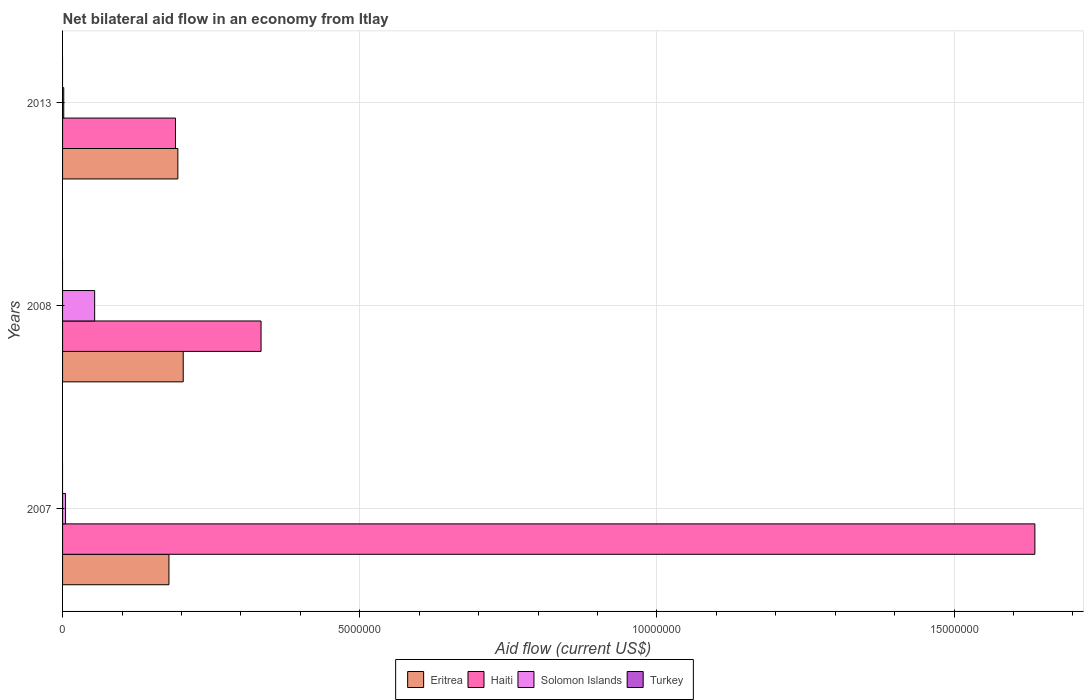Are the number of bars on each tick of the Y-axis equal?
Keep it short and to the point. Yes. What is the label of the 1st group of bars from the top?
Ensure brevity in your answer.  2013. What is the net bilateral aid flow in Turkey in 2013?
Give a very brief answer. 0. Across all years, what is the maximum net bilateral aid flow in Haiti?
Ensure brevity in your answer.  1.64e+07. Across all years, what is the minimum net bilateral aid flow in Eritrea?
Provide a short and direct response. 1.79e+06. What is the total net bilateral aid flow in Eritrea in the graph?
Provide a short and direct response. 5.76e+06. What is the difference between the net bilateral aid flow in Solomon Islands in 2007 and that in 2013?
Give a very brief answer. 3.00e+04. What is the difference between the net bilateral aid flow in Turkey in 2008 and the net bilateral aid flow in Solomon Islands in 2007?
Your answer should be very brief. -5.00e+04. What is the average net bilateral aid flow in Haiti per year?
Provide a short and direct response. 7.20e+06. In the year 2013, what is the difference between the net bilateral aid flow in Eritrea and net bilateral aid flow in Solomon Islands?
Make the answer very short. 1.92e+06. In how many years, is the net bilateral aid flow in Solomon Islands greater than 8000000 US$?
Your answer should be very brief. 0. What is the ratio of the net bilateral aid flow in Haiti in 2008 to that in 2013?
Provide a short and direct response. 1.76. What is the difference between the highest and the second highest net bilateral aid flow in Eritrea?
Offer a terse response. 9.00e+04. What is the difference between the highest and the lowest net bilateral aid flow in Haiti?
Make the answer very short. 1.45e+07. Is the sum of the net bilateral aid flow in Eritrea in 2007 and 2013 greater than the maximum net bilateral aid flow in Haiti across all years?
Provide a short and direct response. No. How many years are there in the graph?
Provide a succinct answer. 3. Does the graph contain any zero values?
Offer a terse response. Yes. Does the graph contain grids?
Your answer should be very brief. Yes. How many legend labels are there?
Provide a succinct answer. 4. What is the title of the graph?
Make the answer very short. Net bilateral aid flow in an economy from Itlay. Does "Bolivia" appear as one of the legend labels in the graph?
Offer a very short reply. No. What is the Aid flow (current US$) of Eritrea in 2007?
Provide a succinct answer. 1.79e+06. What is the Aid flow (current US$) in Haiti in 2007?
Your answer should be very brief. 1.64e+07. What is the Aid flow (current US$) in Eritrea in 2008?
Your answer should be compact. 2.03e+06. What is the Aid flow (current US$) of Haiti in 2008?
Give a very brief answer. 3.34e+06. What is the Aid flow (current US$) in Solomon Islands in 2008?
Give a very brief answer. 5.40e+05. What is the Aid flow (current US$) of Turkey in 2008?
Provide a short and direct response. 0. What is the Aid flow (current US$) in Eritrea in 2013?
Offer a very short reply. 1.94e+06. What is the Aid flow (current US$) of Haiti in 2013?
Ensure brevity in your answer.  1.90e+06. What is the Aid flow (current US$) of Solomon Islands in 2013?
Give a very brief answer. 2.00e+04. Across all years, what is the maximum Aid flow (current US$) in Eritrea?
Your response must be concise. 2.03e+06. Across all years, what is the maximum Aid flow (current US$) in Haiti?
Your answer should be compact. 1.64e+07. Across all years, what is the maximum Aid flow (current US$) in Solomon Islands?
Offer a very short reply. 5.40e+05. Across all years, what is the minimum Aid flow (current US$) in Eritrea?
Give a very brief answer. 1.79e+06. Across all years, what is the minimum Aid flow (current US$) of Haiti?
Keep it short and to the point. 1.90e+06. What is the total Aid flow (current US$) in Eritrea in the graph?
Give a very brief answer. 5.76e+06. What is the total Aid flow (current US$) in Haiti in the graph?
Make the answer very short. 2.16e+07. What is the total Aid flow (current US$) of Solomon Islands in the graph?
Offer a very short reply. 6.10e+05. What is the difference between the Aid flow (current US$) of Haiti in 2007 and that in 2008?
Provide a succinct answer. 1.30e+07. What is the difference between the Aid flow (current US$) of Solomon Islands in 2007 and that in 2008?
Keep it short and to the point. -4.90e+05. What is the difference between the Aid flow (current US$) in Eritrea in 2007 and that in 2013?
Your answer should be compact. -1.50e+05. What is the difference between the Aid flow (current US$) in Haiti in 2007 and that in 2013?
Make the answer very short. 1.45e+07. What is the difference between the Aid flow (current US$) in Haiti in 2008 and that in 2013?
Offer a very short reply. 1.44e+06. What is the difference between the Aid flow (current US$) of Solomon Islands in 2008 and that in 2013?
Your answer should be very brief. 5.20e+05. What is the difference between the Aid flow (current US$) in Eritrea in 2007 and the Aid flow (current US$) in Haiti in 2008?
Offer a very short reply. -1.55e+06. What is the difference between the Aid flow (current US$) of Eritrea in 2007 and the Aid flow (current US$) of Solomon Islands in 2008?
Your answer should be compact. 1.25e+06. What is the difference between the Aid flow (current US$) in Haiti in 2007 and the Aid flow (current US$) in Solomon Islands in 2008?
Give a very brief answer. 1.58e+07. What is the difference between the Aid flow (current US$) of Eritrea in 2007 and the Aid flow (current US$) of Haiti in 2013?
Your answer should be very brief. -1.10e+05. What is the difference between the Aid flow (current US$) of Eritrea in 2007 and the Aid flow (current US$) of Solomon Islands in 2013?
Your response must be concise. 1.77e+06. What is the difference between the Aid flow (current US$) in Haiti in 2007 and the Aid flow (current US$) in Solomon Islands in 2013?
Ensure brevity in your answer.  1.63e+07. What is the difference between the Aid flow (current US$) in Eritrea in 2008 and the Aid flow (current US$) in Solomon Islands in 2013?
Your response must be concise. 2.01e+06. What is the difference between the Aid flow (current US$) in Haiti in 2008 and the Aid flow (current US$) in Solomon Islands in 2013?
Provide a short and direct response. 3.32e+06. What is the average Aid flow (current US$) of Eritrea per year?
Offer a very short reply. 1.92e+06. What is the average Aid flow (current US$) in Haiti per year?
Keep it short and to the point. 7.20e+06. What is the average Aid flow (current US$) of Solomon Islands per year?
Offer a terse response. 2.03e+05. What is the average Aid flow (current US$) of Turkey per year?
Provide a succinct answer. 0. In the year 2007, what is the difference between the Aid flow (current US$) in Eritrea and Aid flow (current US$) in Haiti?
Offer a very short reply. -1.46e+07. In the year 2007, what is the difference between the Aid flow (current US$) in Eritrea and Aid flow (current US$) in Solomon Islands?
Provide a short and direct response. 1.74e+06. In the year 2007, what is the difference between the Aid flow (current US$) of Haiti and Aid flow (current US$) of Solomon Islands?
Offer a very short reply. 1.63e+07. In the year 2008, what is the difference between the Aid flow (current US$) in Eritrea and Aid flow (current US$) in Haiti?
Your answer should be compact. -1.31e+06. In the year 2008, what is the difference between the Aid flow (current US$) of Eritrea and Aid flow (current US$) of Solomon Islands?
Offer a very short reply. 1.49e+06. In the year 2008, what is the difference between the Aid flow (current US$) in Haiti and Aid flow (current US$) in Solomon Islands?
Your answer should be very brief. 2.80e+06. In the year 2013, what is the difference between the Aid flow (current US$) in Eritrea and Aid flow (current US$) in Solomon Islands?
Your response must be concise. 1.92e+06. In the year 2013, what is the difference between the Aid flow (current US$) of Haiti and Aid flow (current US$) of Solomon Islands?
Keep it short and to the point. 1.88e+06. What is the ratio of the Aid flow (current US$) of Eritrea in 2007 to that in 2008?
Your answer should be compact. 0.88. What is the ratio of the Aid flow (current US$) in Haiti in 2007 to that in 2008?
Provide a short and direct response. 4.9. What is the ratio of the Aid flow (current US$) in Solomon Islands in 2007 to that in 2008?
Ensure brevity in your answer.  0.09. What is the ratio of the Aid flow (current US$) of Eritrea in 2007 to that in 2013?
Offer a terse response. 0.92. What is the ratio of the Aid flow (current US$) in Haiti in 2007 to that in 2013?
Provide a succinct answer. 8.61. What is the ratio of the Aid flow (current US$) of Solomon Islands in 2007 to that in 2013?
Provide a short and direct response. 2.5. What is the ratio of the Aid flow (current US$) of Eritrea in 2008 to that in 2013?
Your answer should be compact. 1.05. What is the ratio of the Aid flow (current US$) of Haiti in 2008 to that in 2013?
Give a very brief answer. 1.76. What is the ratio of the Aid flow (current US$) of Solomon Islands in 2008 to that in 2013?
Provide a succinct answer. 27. What is the difference between the highest and the second highest Aid flow (current US$) in Eritrea?
Offer a very short reply. 9.00e+04. What is the difference between the highest and the second highest Aid flow (current US$) in Haiti?
Offer a terse response. 1.30e+07. What is the difference between the highest and the second highest Aid flow (current US$) in Solomon Islands?
Provide a succinct answer. 4.90e+05. What is the difference between the highest and the lowest Aid flow (current US$) of Haiti?
Your answer should be compact. 1.45e+07. What is the difference between the highest and the lowest Aid flow (current US$) of Solomon Islands?
Offer a very short reply. 5.20e+05. 